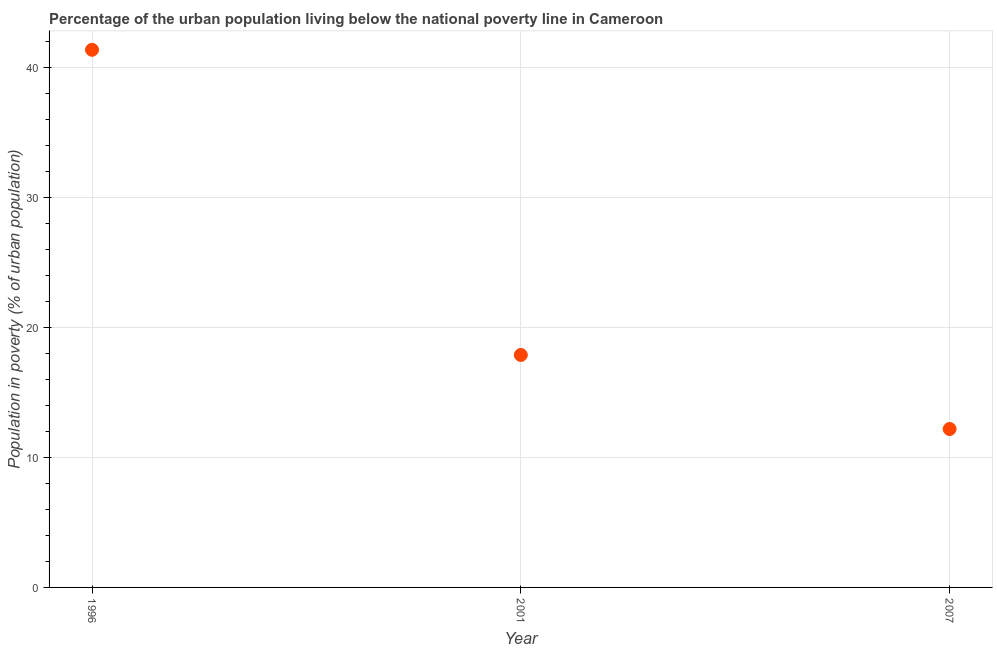Across all years, what is the maximum percentage of urban population living below poverty line?
Your answer should be compact. 41.4. Across all years, what is the minimum percentage of urban population living below poverty line?
Provide a succinct answer. 12.2. In which year was the percentage of urban population living below poverty line minimum?
Provide a succinct answer. 2007. What is the sum of the percentage of urban population living below poverty line?
Your response must be concise. 71.5. What is the difference between the percentage of urban population living below poverty line in 1996 and 2007?
Ensure brevity in your answer.  29.2. What is the average percentage of urban population living below poverty line per year?
Your answer should be compact. 23.83. What is the ratio of the percentage of urban population living below poverty line in 2001 to that in 2007?
Your response must be concise. 1.47. What is the difference between the highest and the second highest percentage of urban population living below poverty line?
Your answer should be compact. 23.5. What is the difference between the highest and the lowest percentage of urban population living below poverty line?
Your answer should be compact. 29.2. In how many years, is the percentage of urban population living below poverty line greater than the average percentage of urban population living below poverty line taken over all years?
Offer a very short reply. 1. Does the percentage of urban population living below poverty line monotonically increase over the years?
Give a very brief answer. No. How many dotlines are there?
Your answer should be very brief. 1. How many years are there in the graph?
Ensure brevity in your answer.  3. Does the graph contain any zero values?
Offer a very short reply. No. What is the title of the graph?
Ensure brevity in your answer.  Percentage of the urban population living below the national poverty line in Cameroon. What is the label or title of the Y-axis?
Offer a very short reply. Population in poverty (% of urban population). What is the Population in poverty (% of urban population) in 1996?
Keep it short and to the point. 41.4. What is the Population in poverty (% of urban population) in 2001?
Your answer should be compact. 17.9. What is the Population in poverty (% of urban population) in 2007?
Offer a terse response. 12.2. What is the difference between the Population in poverty (% of urban population) in 1996 and 2001?
Provide a short and direct response. 23.5. What is the difference between the Population in poverty (% of urban population) in 1996 and 2007?
Provide a succinct answer. 29.2. What is the ratio of the Population in poverty (% of urban population) in 1996 to that in 2001?
Provide a succinct answer. 2.31. What is the ratio of the Population in poverty (% of urban population) in 1996 to that in 2007?
Provide a short and direct response. 3.39. What is the ratio of the Population in poverty (% of urban population) in 2001 to that in 2007?
Offer a very short reply. 1.47. 